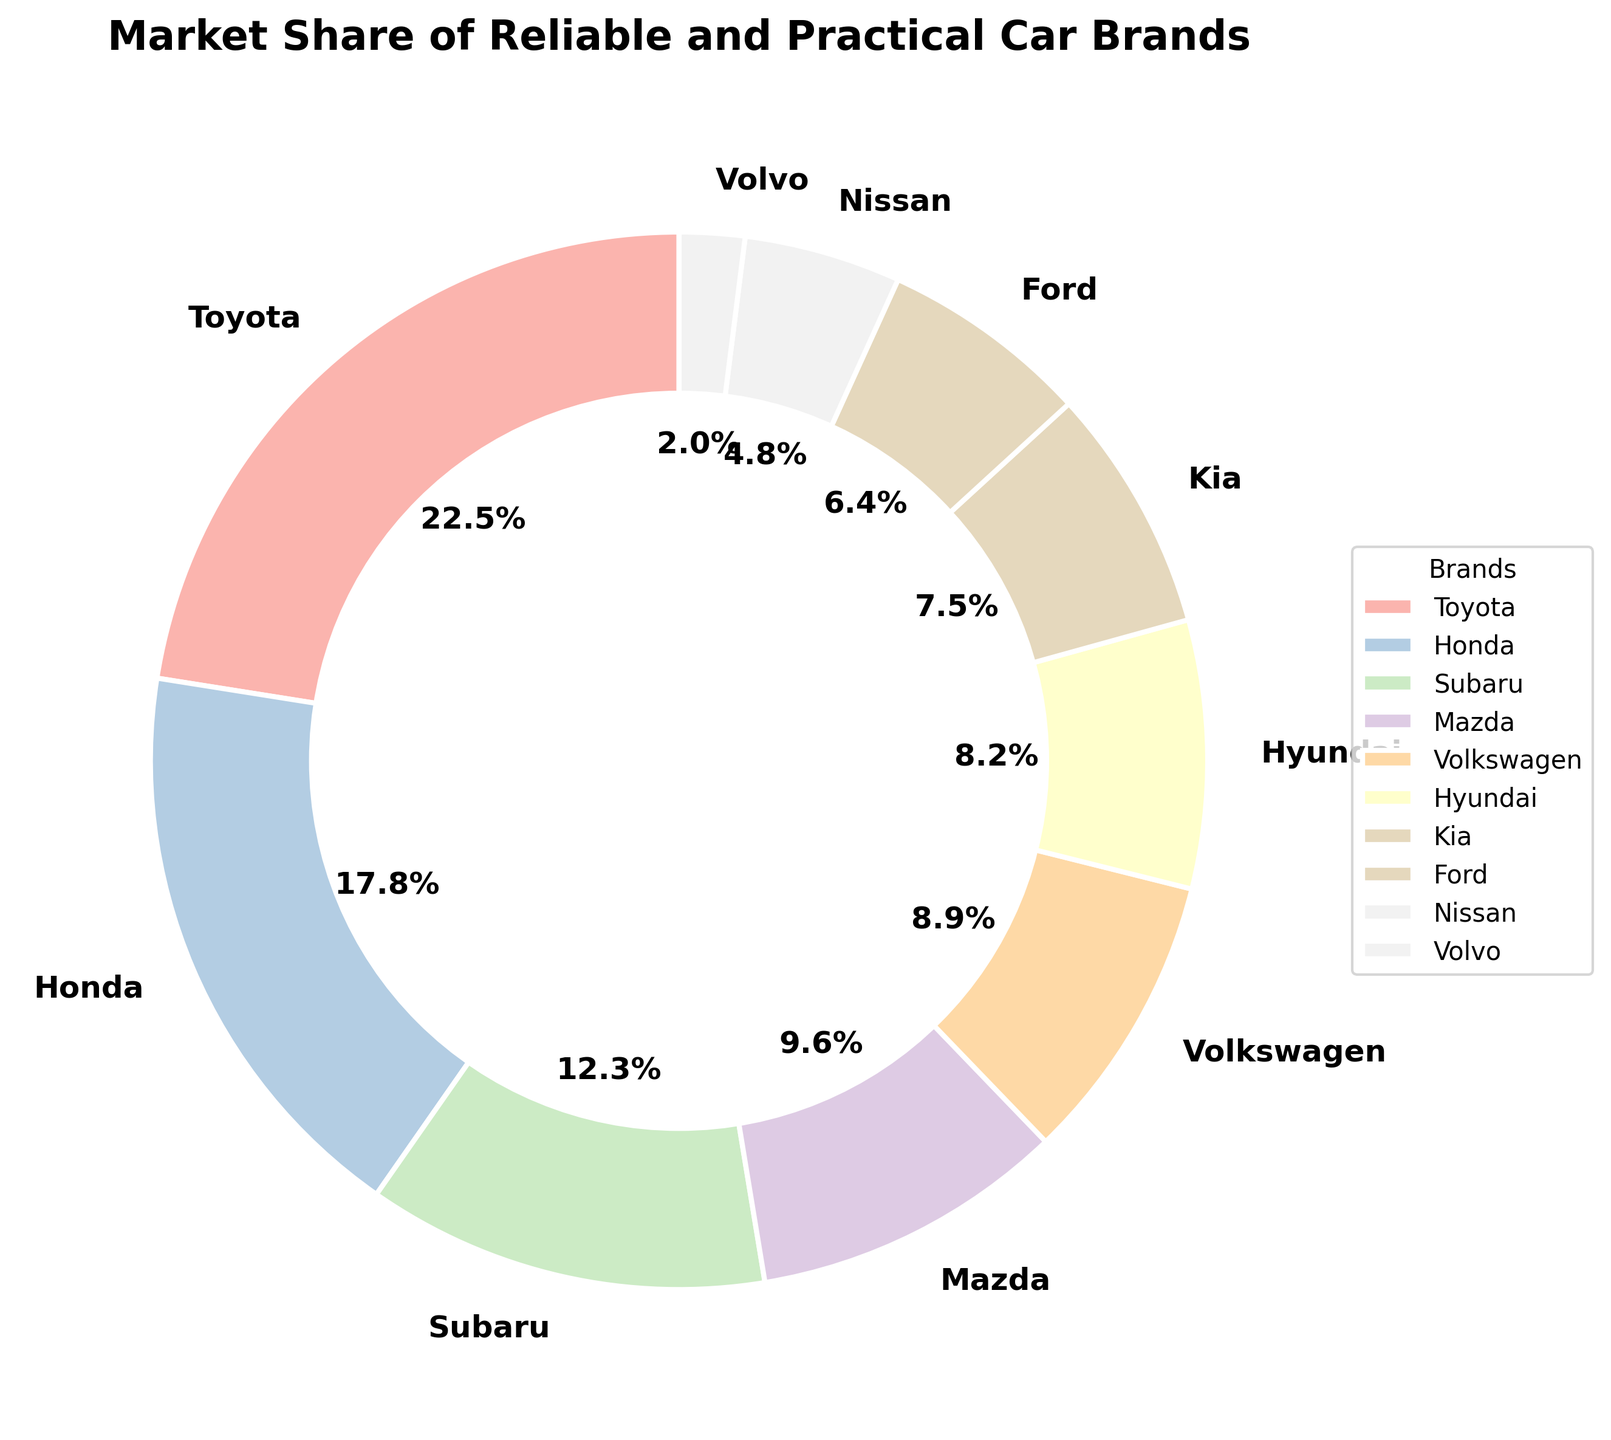Which brand has the largest market share? By looking at the chart, identify the brand with the largest slice of the pie, denoted by its percentage.
Answer: Toyota What is the combined market share of Hyundai and Kia? Locate the market share percentages of Hyundai (8.2%) and Kia (7.5%) on the chart. Add these two percentages together: 8.2 + 7.5 = 15.7.
Answer: 15.7% How many brands have a market share greater than 10%? Check each brand's market share percentage on the chart. Count the brands with percentages greater than 10%. Those are Toyota (22.5%), Honda (17.8%), and Subaru (12.3%).
Answer: 3 What is the difference in market share between Toyota and Honda? Find the market shares of Toyota (22.5%) and Honda (17.8%) from the chart. Subtract Honda's share from Toyota's share: 22.5 - 17.8.
Answer: 4.7% Which brand has the smallest market share? Look for the brand with the smallest slice of the pie chart. The smallest percentage displayed is 2.0%, corresponding to Volvo.
Answer: Volvo Is the market share of Mazda more than that of Volkswagen? Compare the market shares of Mazda (9.6%) and Volkswagen (8.9%) on the chart. Since 9.6 is greater than 8.9, Mazda has a higher market share.
Answer: Yes Which brands occupy the bottom three positions in market share? Identify the three smallest slices in the pie chart, denoted as Volvo (2.0%), Nissan (4.8%), and Ford (6.4%).
Answer: Volvo, Nissan, Ford What percentage of the market share is held by Toyota, Honda, and Subaru combined? Sum up the market shares of Toyota (22.5%), Honda (17.8%), and Subaru (12.3%) by adding their percentages together: 22.5 + 17.8 + 12.3 = 52.6.
Answer: 52.6% What is the average market share of Honda, Subaru, and Mazda? Add the market shares of Honda (17.8%), Subaru (12.3%), and Mazda (9.6%), then divide by the number of brands: (17.8 + 12.3 + 9.6) / 3 = 39.7 / 3.
Answer: 13.2% 